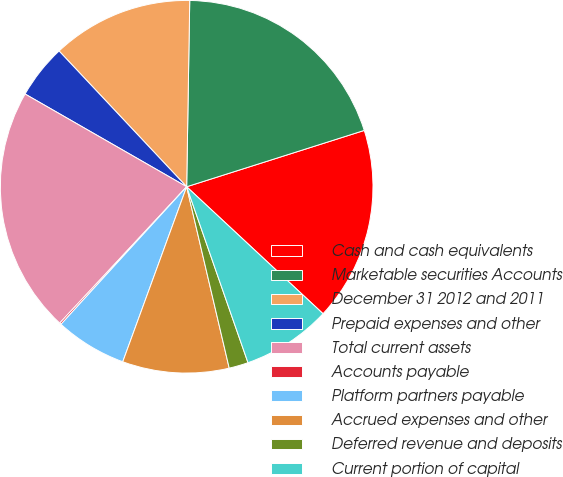Convert chart to OTSL. <chart><loc_0><loc_0><loc_500><loc_500><pie_chart><fcel>Cash and cash equivalents<fcel>Marketable securities Accounts<fcel>December 31 2012 and 2011<fcel>Prepaid expenses and other<fcel>Total current assets<fcel>Accounts payable<fcel>Platform partners payable<fcel>Accrued expenses and other<fcel>Deferred revenue and deposits<fcel>Current portion of capital<nl><fcel>16.82%<fcel>19.85%<fcel>12.27%<fcel>4.7%<fcel>21.36%<fcel>0.15%<fcel>6.21%<fcel>9.24%<fcel>1.67%<fcel>7.73%<nl></chart> 